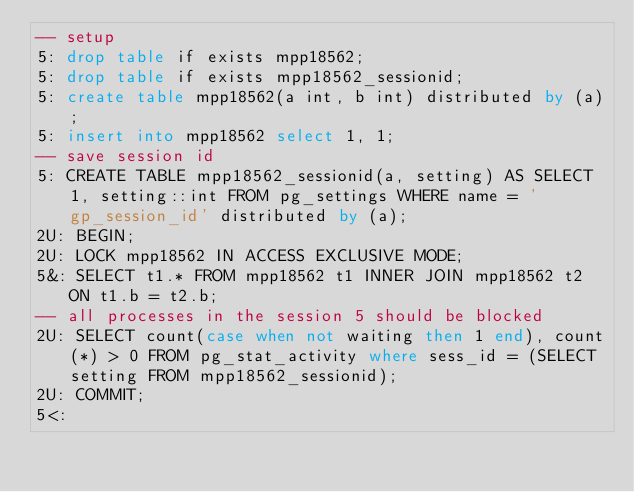Convert code to text. <code><loc_0><loc_0><loc_500><loc_500><_SQL_>-- setup
5: drop table if exists mpp18562;
5: drop table if exists mpp18562_sessionid;
5: create table mpp18562(a int, b int) distributed by (a);
5: insert into mpp18562 select 1, 1;
-- save session id
5: CREATE TABLE mpp18562_sessionid(a, setting) AS SELECT 1, setting::int FROM pg_settings WHERE name = 'gp_session_id' distributed by (a);
2U: BEGIN;
2U: LOCK mpp18562 IN ACCESS EXCLUSIVE MODE;
5&: SELECT t1.* FROM mpp18562 t1 INNER JOIN mpp18562 t2 ON t1.b = t2.b;
-- all processes in the session 5 should be blocked
2U: SELECT count(case when not waiting then 1 end), count(*) > 0 FROM pg_stat_activity where sess_id = (SELECT setting FROM mpp18562_sessionid);
2U: COMMIT;
5<:
</code> 